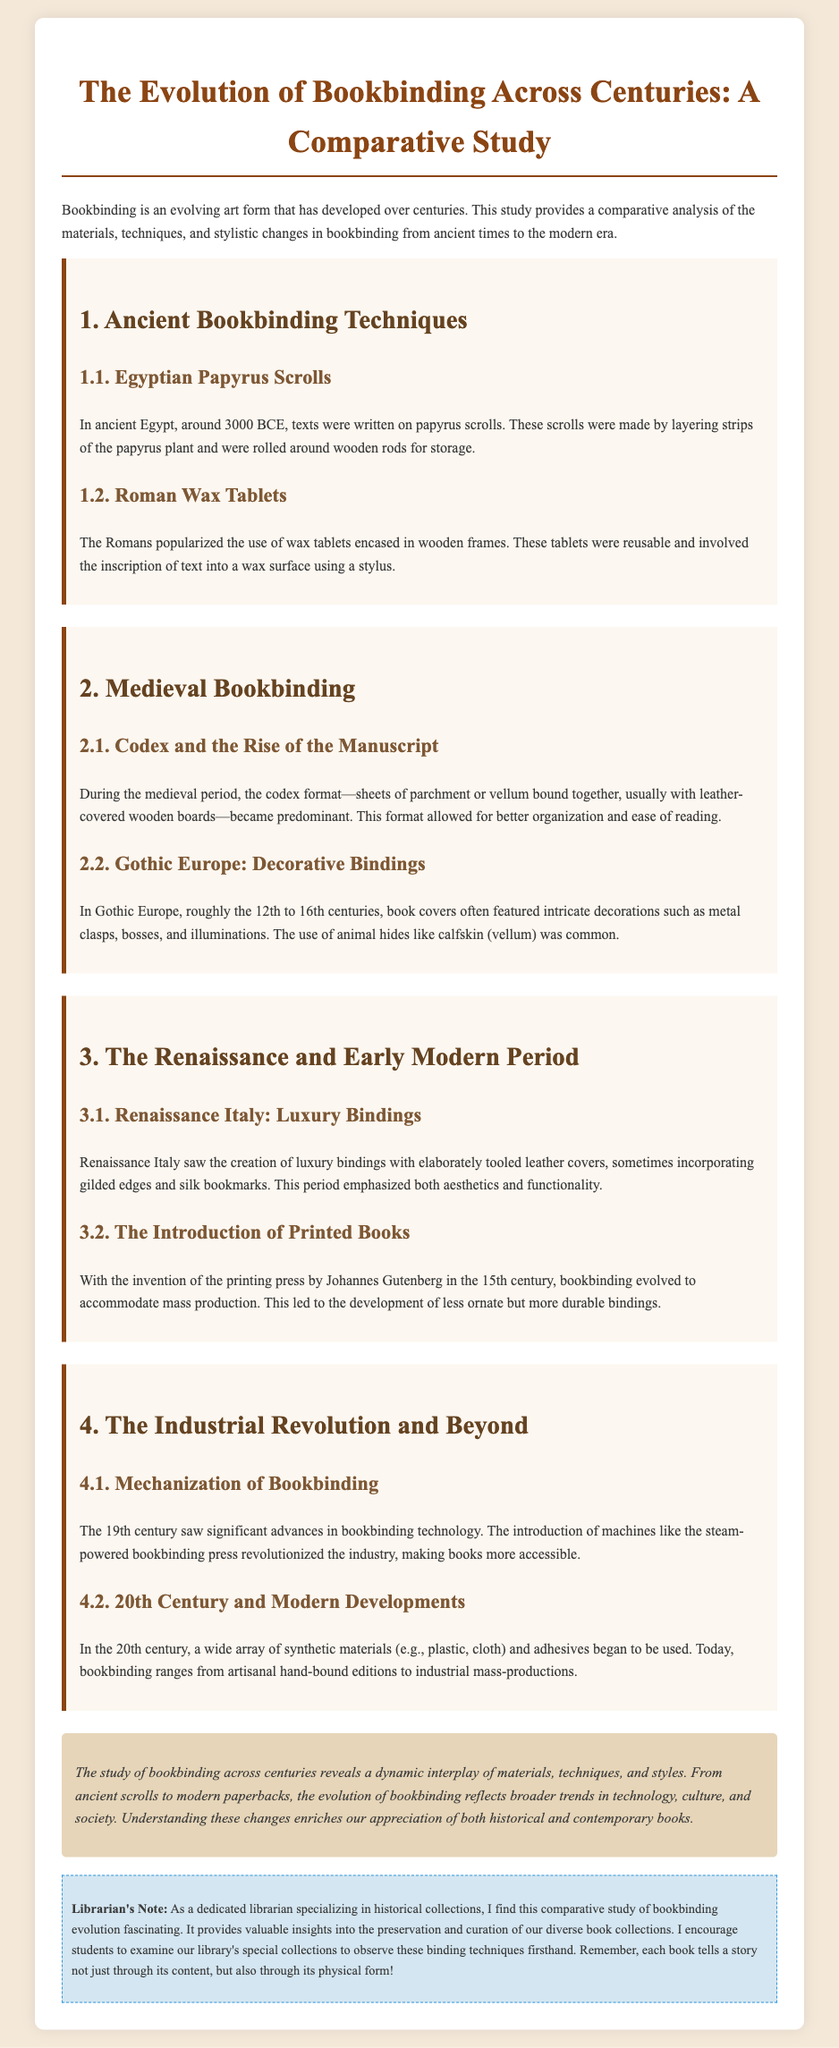what are the materials used for Egyptian papyrus scrolls? The scrolls were made by layering strips of the papyrus plant.
Answer: strips of the papyrus plant what was the predominant book format during the medieval period? The codex format became predominant in the medieval period.
Answer: codex which period introduced the use of the printing press? The printing press was invented by Johannes Gutenberg in the 15th century.
Answer: 15th century what type of binding became popular in Renaissance Italy? Luxury bindings with elaborately tooled leather covers were popular.
Answer: luxury bindings what significant technological advancement emerged in the 19th century? The introduction of machines like the steam-powered bookbinding press revolutionized the industry.
Answer: steam-powered bookbinding press what is a key characteristic of Gothic Europe book covers? Book covers often featured intricate decorations such as metal clasps, bosses, and illuminations.
Answer: intricate decorations which century saw the use of synthetic materials in bookbinding? The 20th century saw the use of synthetic materials begin.
Answer: 20th century what is a major effect of the mechanization of bookbinding? It made books more accessible.
Answer: more accessible what does the librarian's note encourage students to do? The librarian's note encourages students to examine the library's special collections.
Answer: examine the library's special collections 